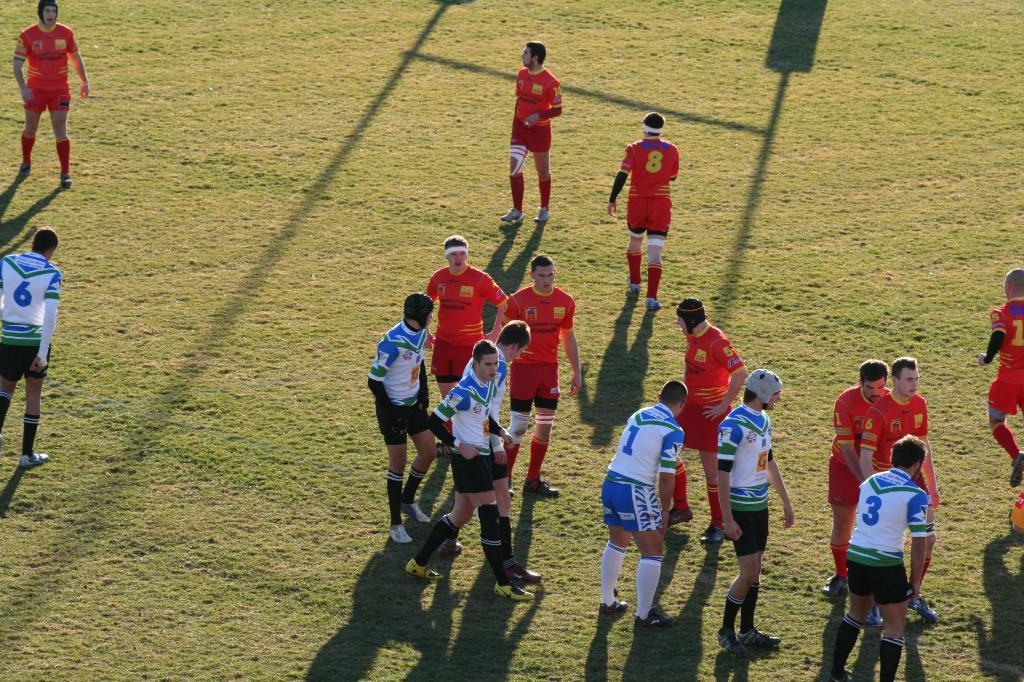<image>
Write a terse but informative summary of the picture. A man with the number 3 on his shirt is on the field. 